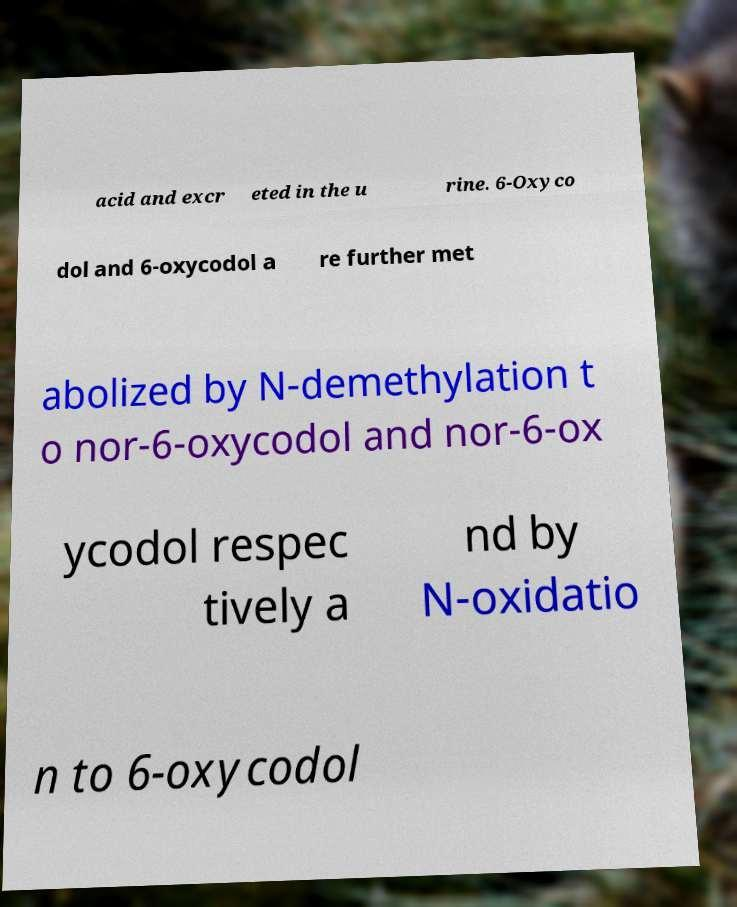Can you read and provide the text displayed in the image?This photo seems to have some interesting text. Can you extract and type it out for me? acid and excr eted in the u rine. 6-Oxyco dol and 6-oxycodol a re further met abolized by N-demethylation t o nor-6-oxycodol and nor-6-ox ycodol respec tively a nd by N-oxidatio n to 6-oxycodol 